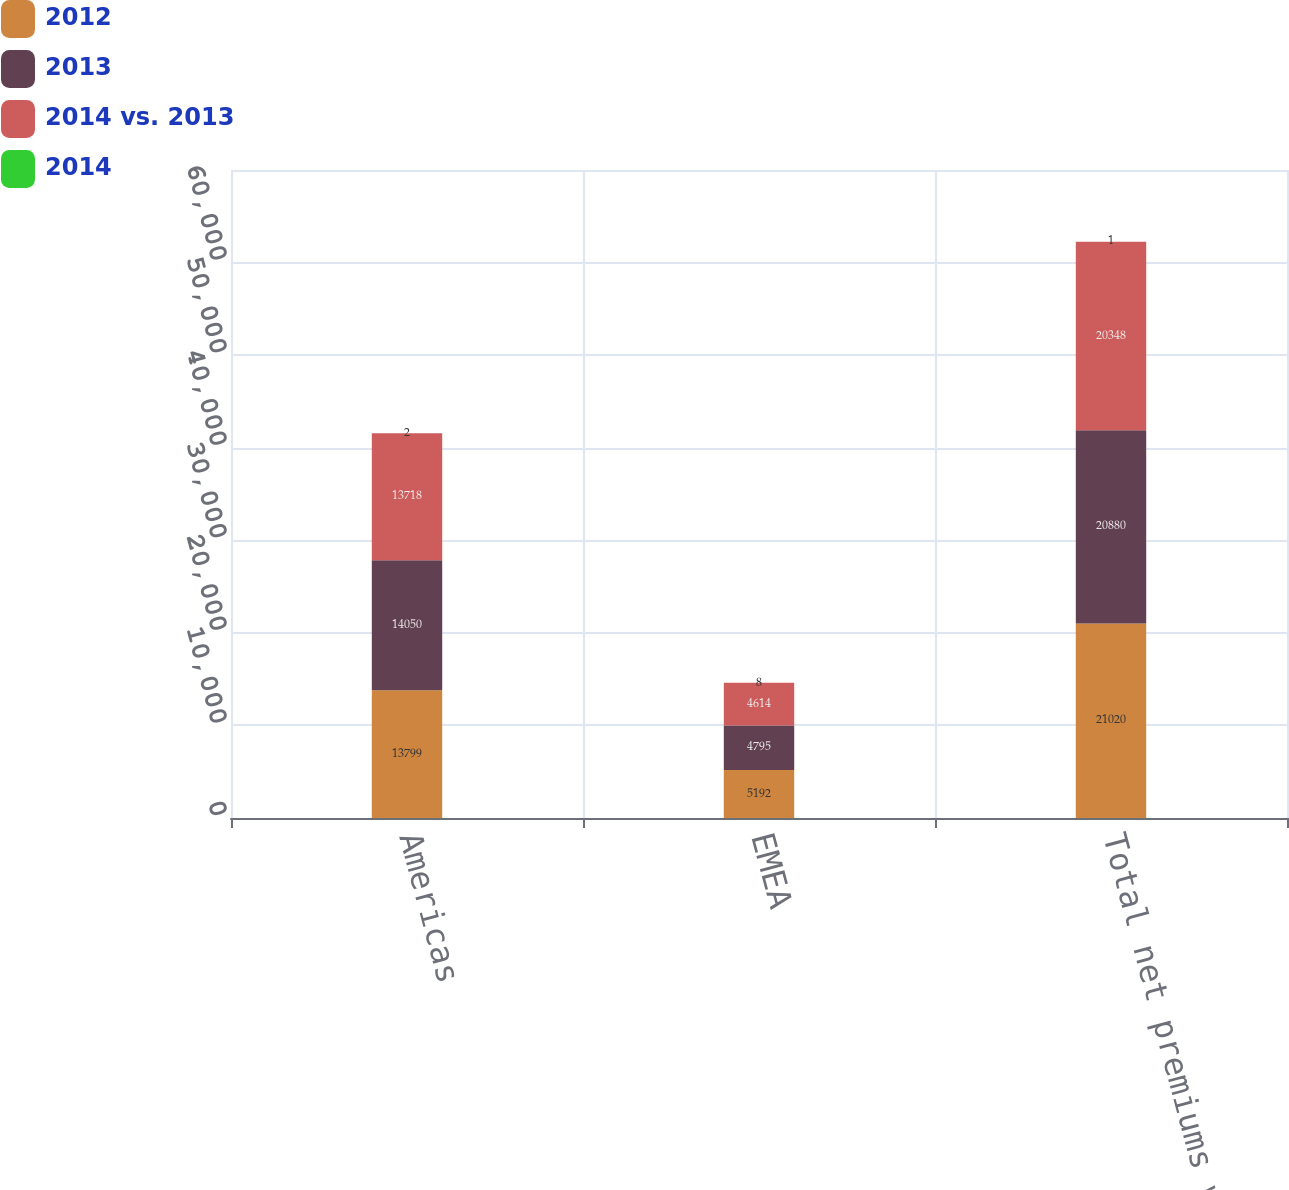Convert chart. <chart><loc_0><loc_0><loc_500><loc_500><stacked_bar_chart><ecel><fcel>Americas<fcel>EMEA<fcel>Total net premiums written<nl><fcel>2012<fcel>13799<fcel>5192<fcel>21020<nl><fcel>2013<fcel>14050<fcel>4795<fcel>20880<nl><fcel>2014 vs. 2013<fcel>13718<fcel>4614<fcel>20348<nl><fcel>2014<fcel>2<fcel>8<fcel>1<nl></chart> 